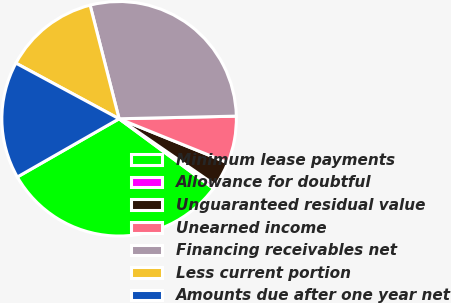Convert chart. <chart><loc_0><loc_0><loc_500><loc_500><pie_chart><fcel>Minimum lease payments<fcel>Allowance for doubtful<fcel>Unguaranteed residual value<fcel>Unearned income<fcel>Financing receivables net<fcel>Less current portion<fcel>Amounts due after one year net<nl><fcel>31.61%<fcel>0.51%<fcel>3.49%<fcel>6.48%<fcel>28.62%<fcel>13.15%<fcel>16.14%<nl></chart> 